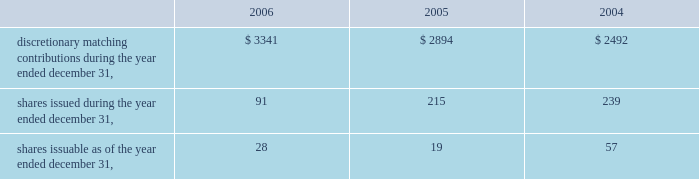Vertex pharmaceuticals incorporated notes to consolidated financial statements ( continued ) o .
Significant revenue arrangements ( continued ) $ 7 million of development and commercialization milestone payments .
Additionally , kissei agreed to reimburse the company for certain development costs , including a portion of costs for phase 2 trials of vx-702 .
Research funding ended under this program in june 2000 , and the company has received the full amount of research funding specified under the agreement .
Kissei has exclusive rights to develop and commercialize vx-702 in japan and certain far east countries and co-exclusive rights in china , taiwan and south korea .
The company retains exclusive marketing rights outside the far east and co-exclusive rights in china , taiwan and south korea .
In addition , the company will have the right to supply bulk drug material to kissei for sale in its territory and will receive royalties or drug supply payments on future product sales , if any .
In 2006 , 2005 and 2004 , approximately $ 6.4 million , $ 7.3 million and $ 3.5 million , respectively , was recognized as revenue under this agreement .
The $ 7.3 million of revenue recognized in 2005 includes a $ 2.5 million milestone paid upon kissei 2019s completion of regulatory filings in preparation for phase 1 clinical development of vx-702 in japan .
Employee benefits the company has a 401 ( k ) retirement plan ( the 201cvertex 401 ( k ) plan 201d ) in which substantially all of its permanent employees are eligible to participate .
Participants may contribute up to 60% ( 60 % ) of their annual compensation to the vertex 401 ( k ) plan , subject to statutory limitations .
The company may declare discretionary matching contributions to the vertex 401 ( k ) plan that are payable in the form of vertex common stock .
The match is paid in the form of fully vested interests in a vertex common stock fund .
Employees have the ability to transfer funds from the company stock fund as they choose .
The company declared matching contributions to the vertex 401 ( k ) plan as follows ( in thousands ) : q .
Related party transactions as of december 31 , 2006 , 2005 and 2004 , the company had a loan outstanding to a former officer of the company in the amount of $ 36000 , $ 36000 , $ 97000 , respectively , which was initially advanced in april 2002 .
The loan balance is included in other assets on the consolidated balance sheets .
In 2001 , the company entered into a four year consulting agreement with a director of the company for the provision of part-time consulting services over a period of four years , at the rate of $ 80000 per year commencing in january 2002 .
The consulting agreement terminated in january 2006 .
Contingencies the company has certain contingent liabilities that arise in the ordinary course of its business activities .
The company accrues a reserve for contingent liabilities when it is probable that future expenditures will be made and such expenditures can be reasonably estimated. .
Discretionary matching contributions during the year ended december 31 , $ 3341 $ 2894 $ 2492 shares issued during the year ended december 31 , 91 215 239 shares issuable as of the year ended december 31 , 28 19 57 .
What is the percent change in share issuable between the end of 2006 and the end of 2005? 
Computations: ((28 - 19) / 19)
Answer: 0.47368. 